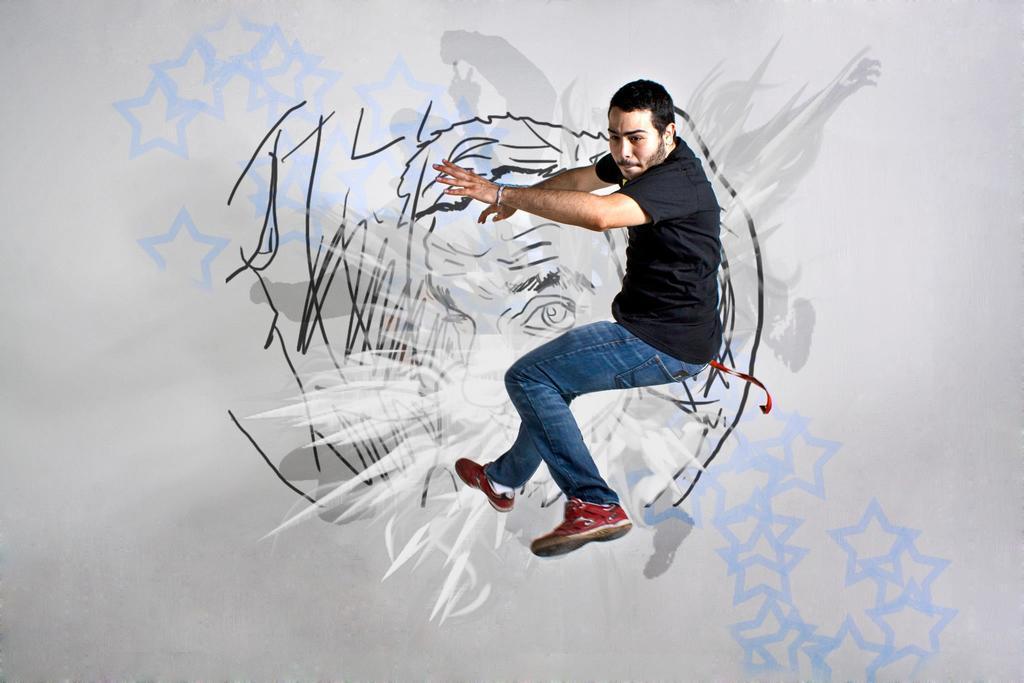Can you describe this image briefly? There is a man in motion. In the background we can see drawing and it is white color. 